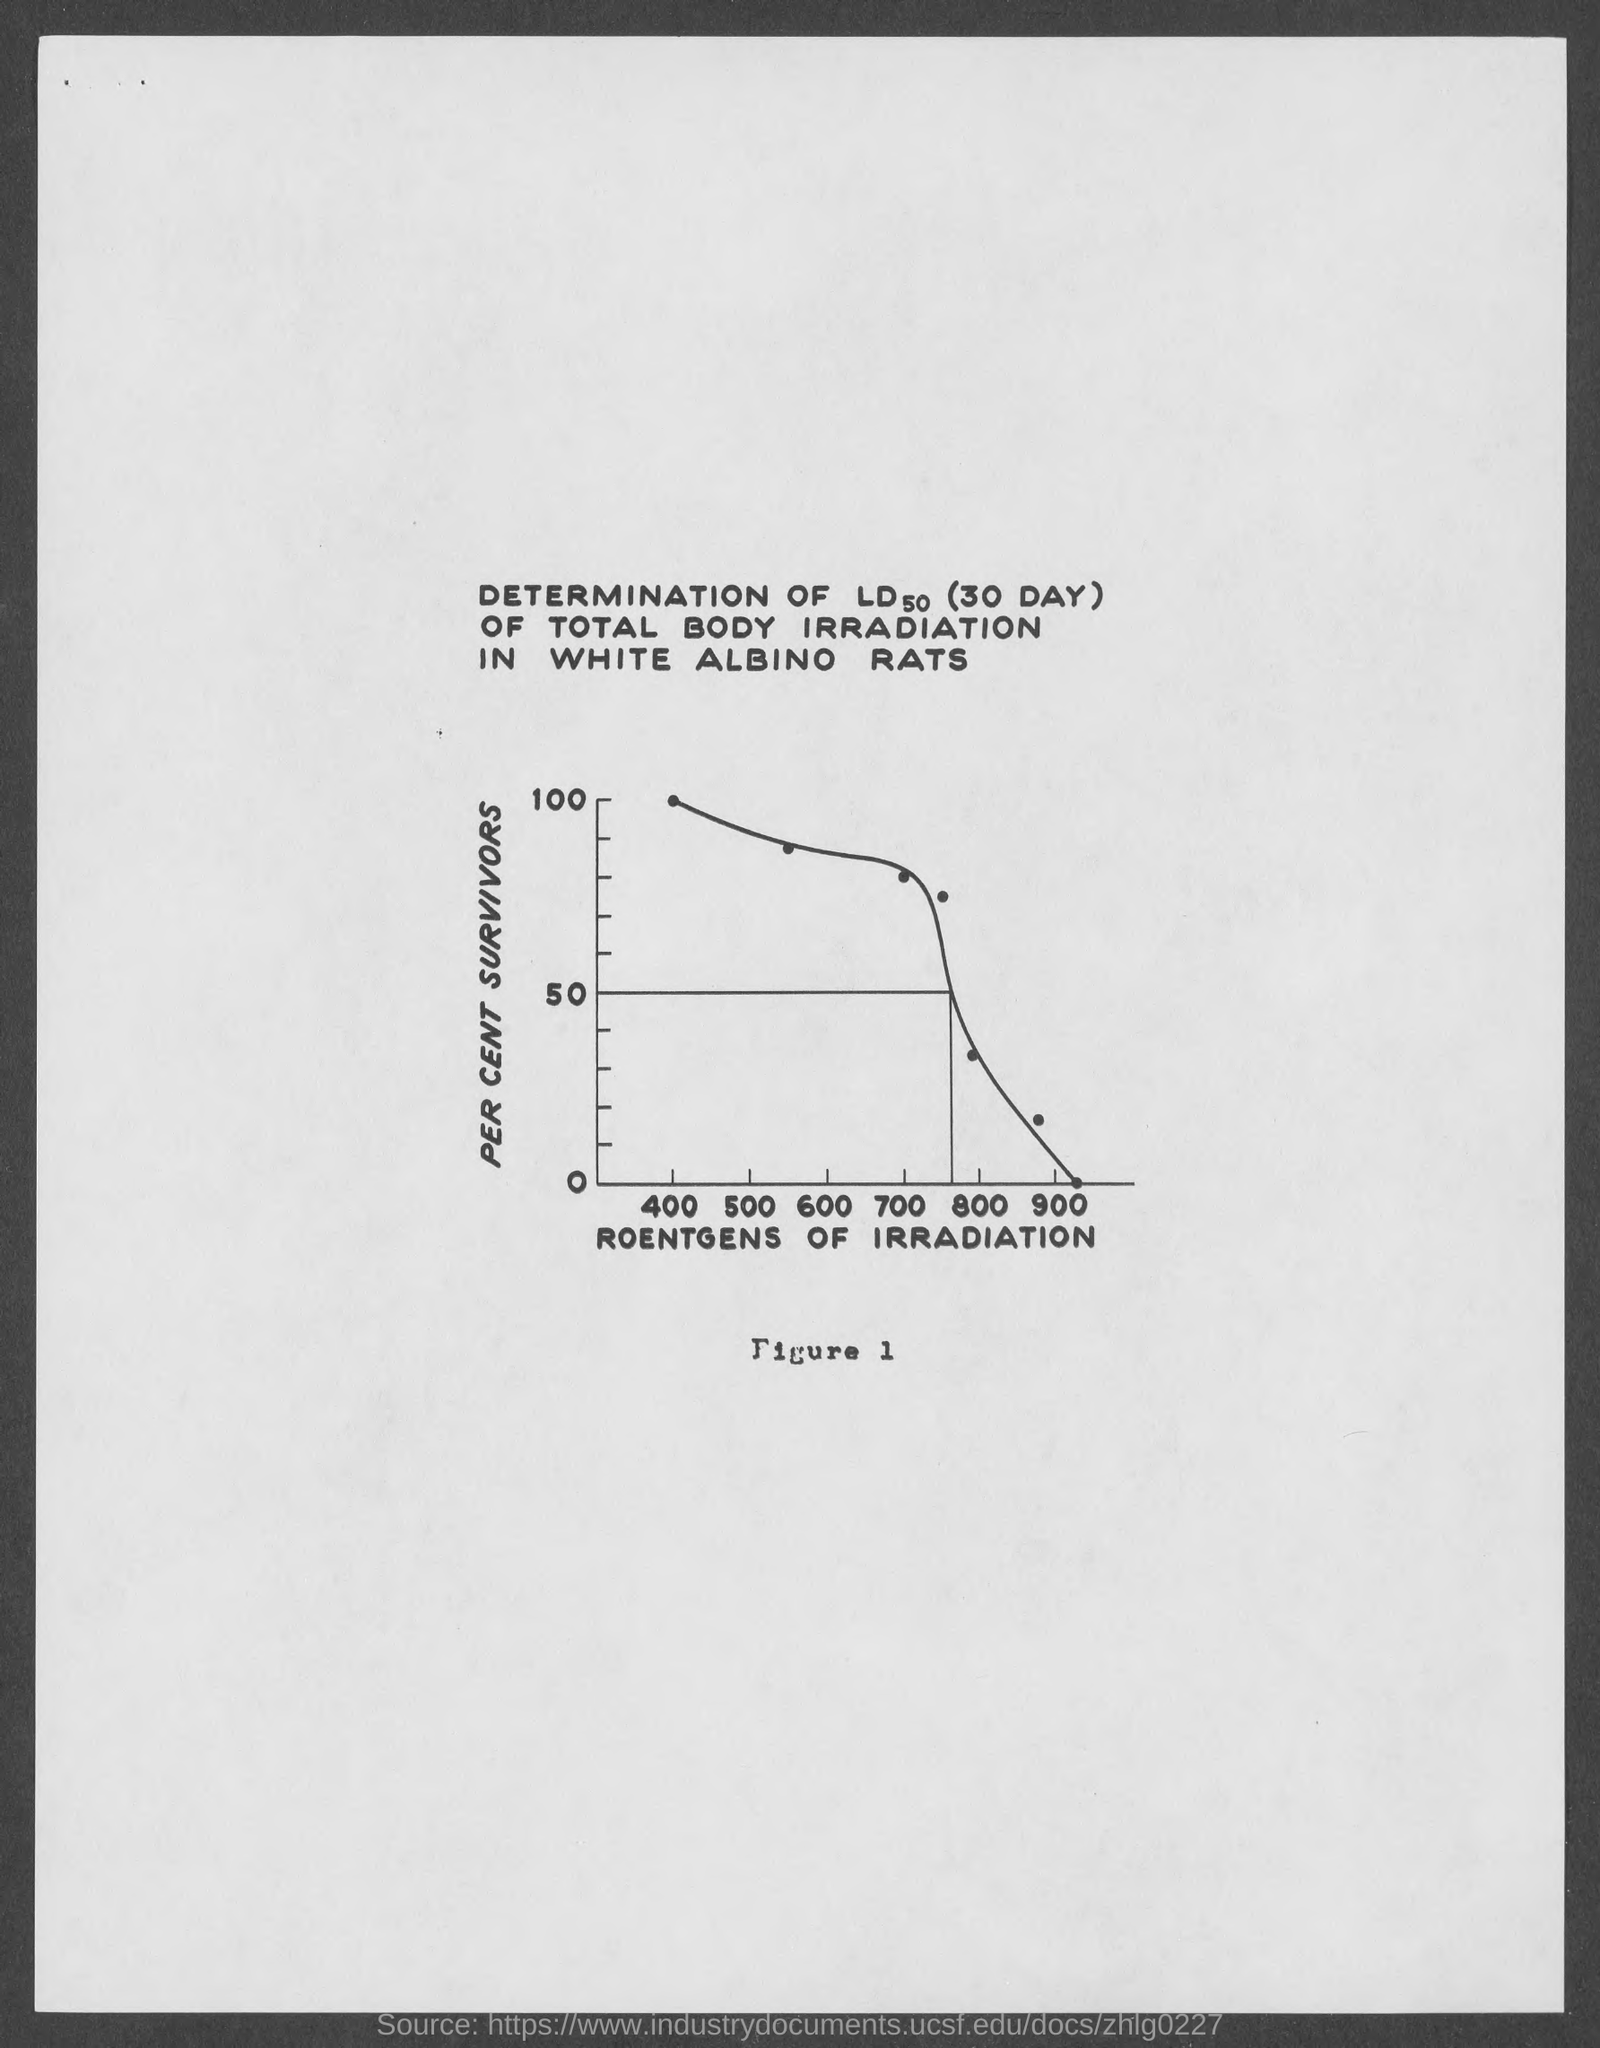Indicate a few pertinent items in this graphic. The y-axis represents the percentage of survivors. The x-axis indicates the amount of roentgen radiation exposure in units of rads. 